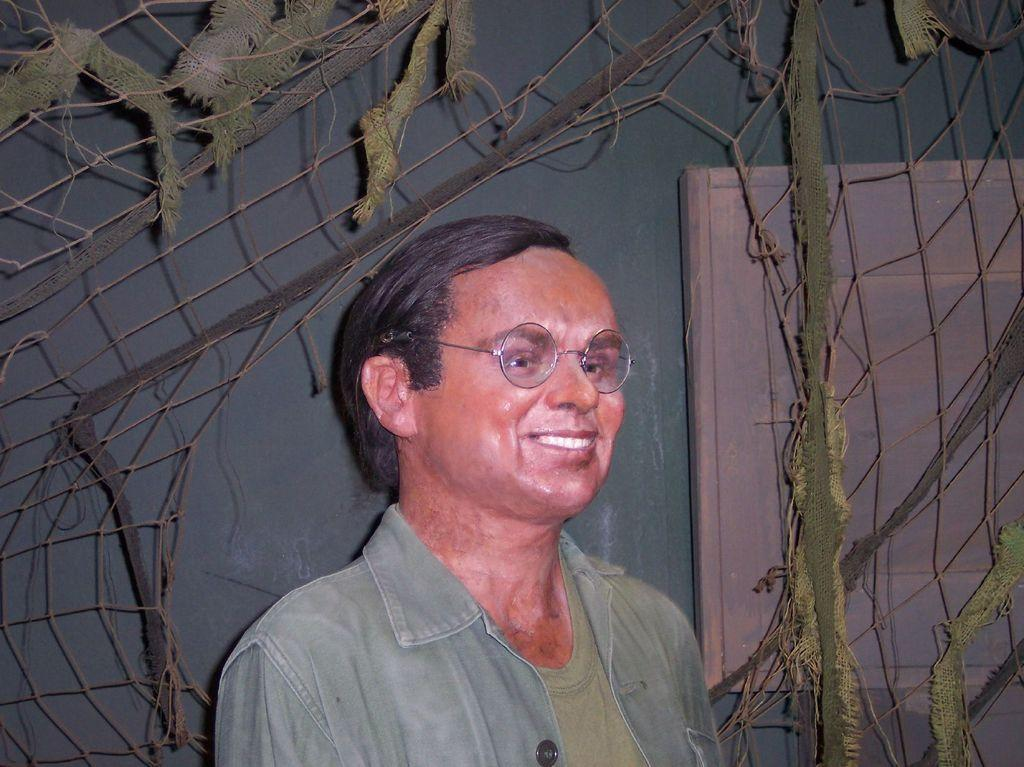What can be seen in the image? There is a person in the image. Can you describe the person's appearance? The person is wearing clothes and spectacles. What is in front of the wall in the image? There is a net in front of a wall in the image. What architectural feature can be seen on the right side of the image? There is a window door on the right side of the image. What is the aftermath of the earthquake in the image? There is no earthquake or aftermath mentioned or depicted in the image. Can you describe the yoke that the person is using in the image? There is no yoke present in the image; the person is simply standing and wearing spectacles. 